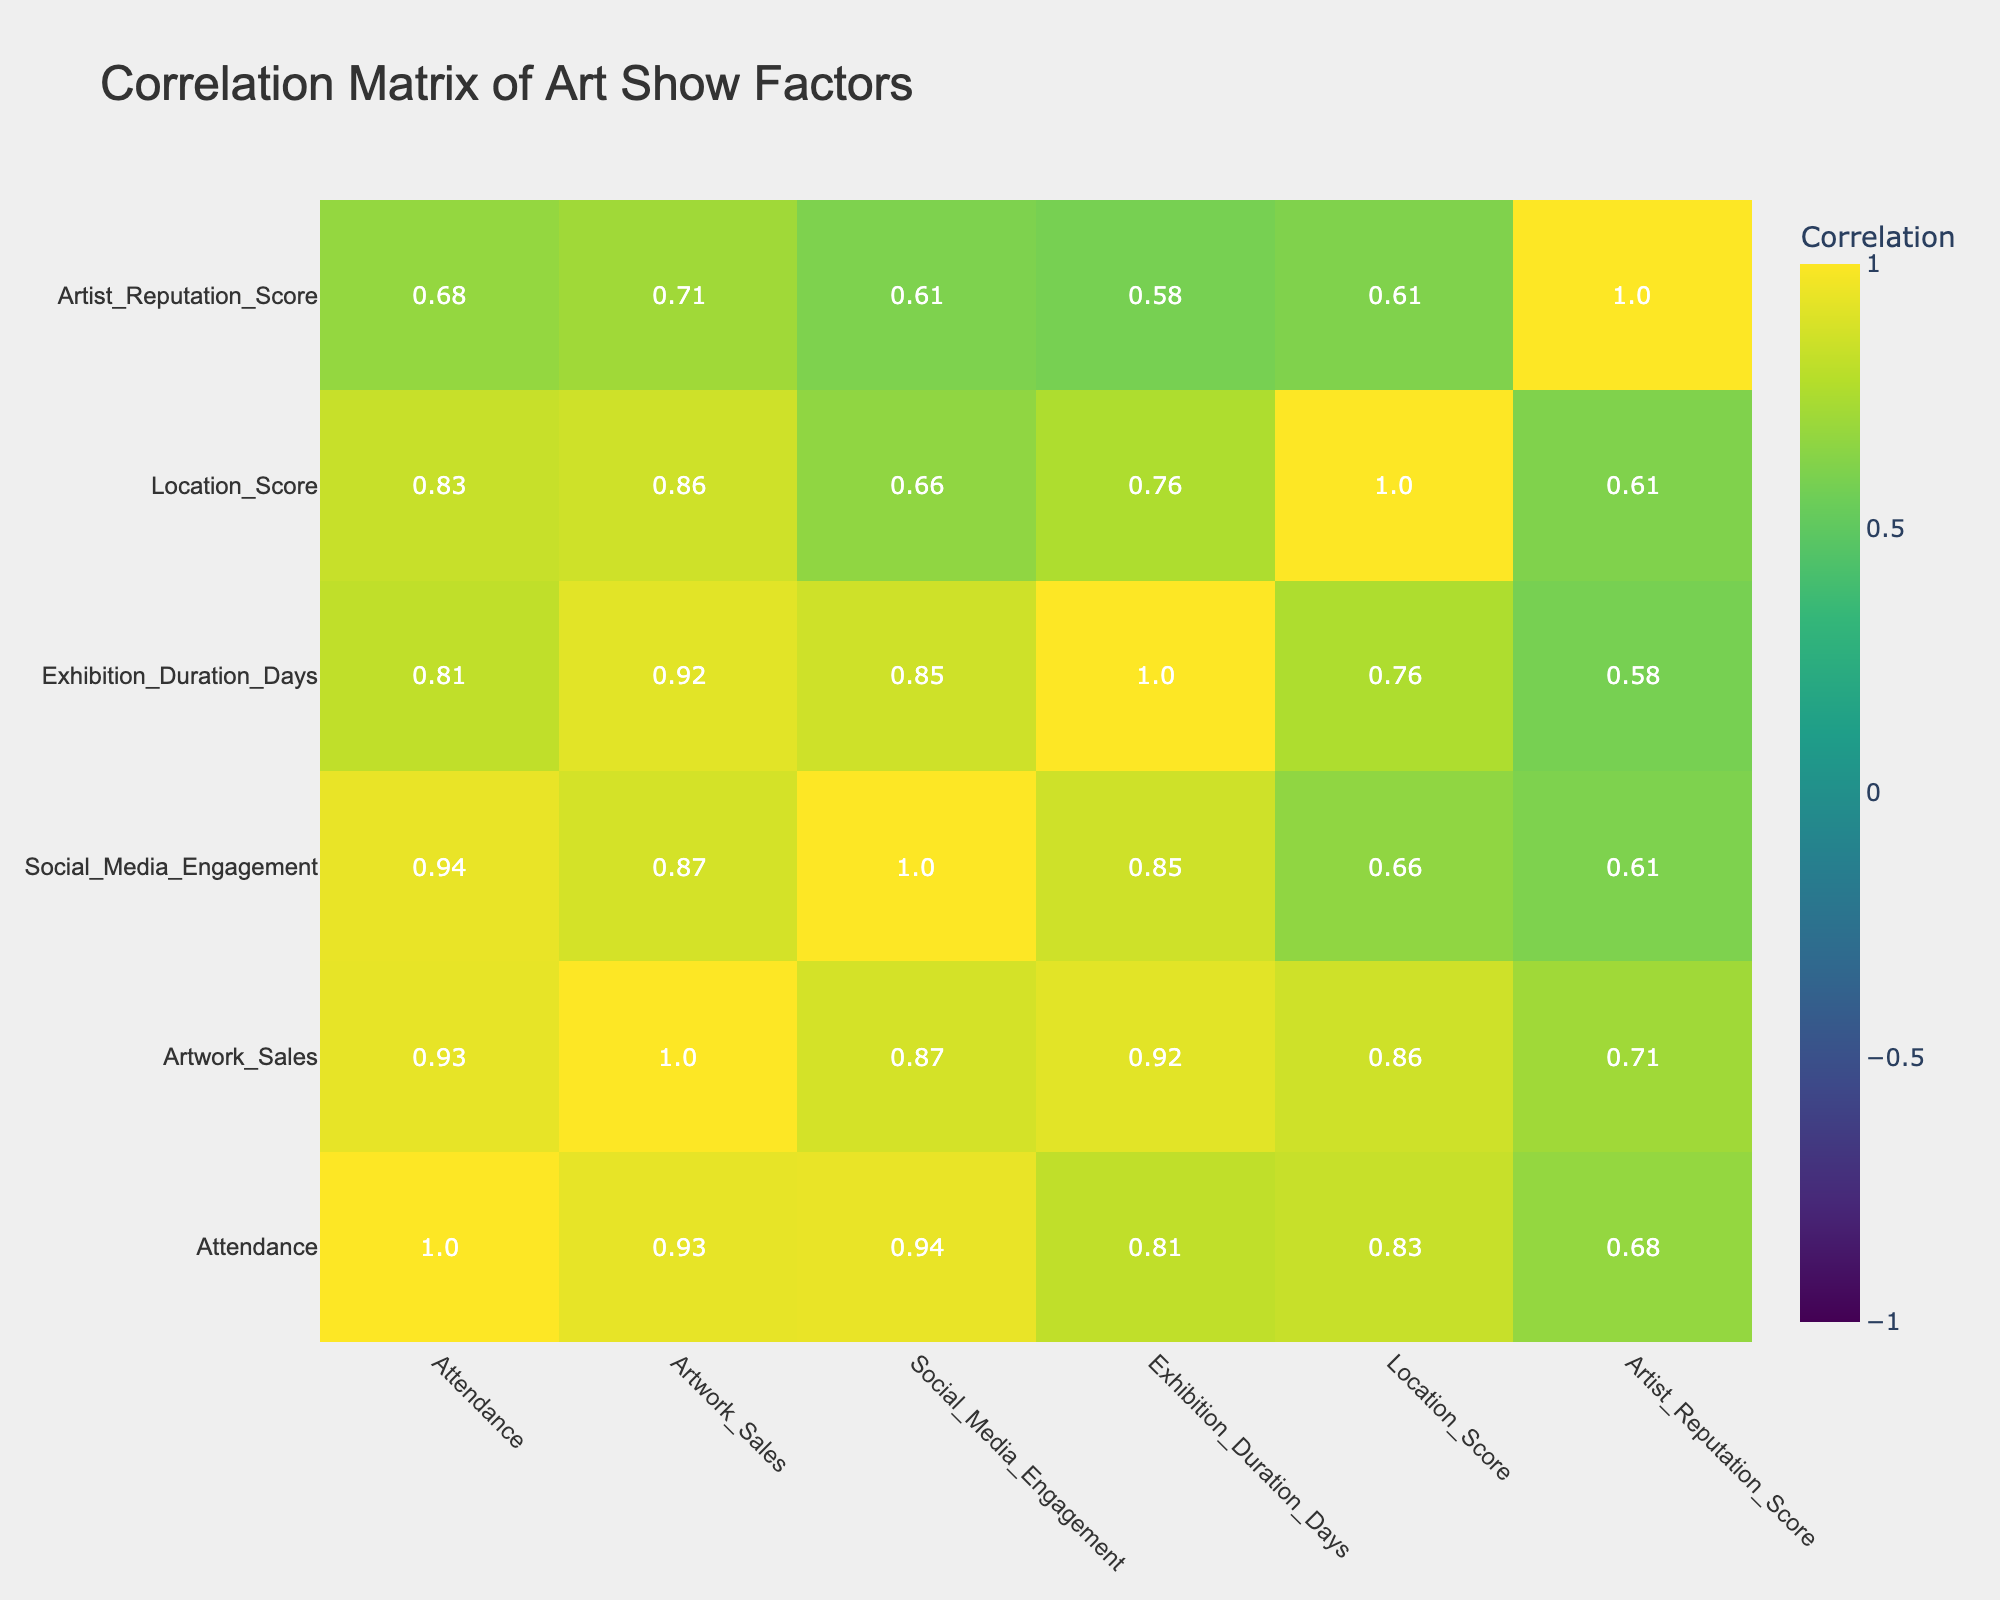What is the attendance at Rotterdam Art Fair? The table shows the attendance for each art show. Looking at the row for Rotterdam Art Fair, the attendance is listed as 2500.
Answer: 2500 What is the total artwork sales for all shows combined? To find the total artwork sales, we sum the values in the Artwork Sales column: 30000 + 45000 + 12000 + 18000 + 25000 + 8000 + 15000 + 35000 = 168000.
Answer: 168000 Is the Social Media Engagement score higher for the Amsterdam Spring Show compared to Groningen Fine Art Show? The table lists the Social Media Engagement scores as 200 for Amsterdam Spring Show and 75 for Groningen Fine Art Show. Since 200 is greater than 75, the statement is true.
Answer: Yes What is the average attendance of the shows held in cities with a Location Score of 8 or more? From the data, the shows with a Location Score of 8 or more are Rotterdam Art Fair (2500), Amsterdam Spring Show (1500), and Nijmegen Contemporary Art (1300). The total attendance for these is 2500 + 1500 + 1300 = 5300. There are three shows, so the average attendance is 5300 / 3 = approximately 1766.67.
Answer: 1766.67 Which show has the highest Artist Reputation Score? The Artist Reputation Scores for the shows are as follows: Amsterdam Spring Show (9), Rotterdam Art Fair (8), Utrecht Modern Art (6), Den Haag Painting Exhibition (7), Eindhoven Innovative Arts (8), Groningen Fine Art Show (5), Leiden Art Weekend (7), and Nijmegen Contemporary Art (7). The highest score is 9 for Amsterdam Spring Show.
Answer: Amsterdam Spring Show How is the relationship between Exhibition Duration Days and Artwork Sales? To determine the relationship, we can look for the correlation coefficient between Exhibition Duration Days and Artwork Sales in the correlation table. If it's close to 1 or -1, that indicates a strong relationship; however, if it’s close to 0, it indicates a weak relationship. Checking the table, we see that the correlation coefficient is approximately 0.72, indicating a positive relationship.
Answer: Strong positive correlation Which city has the lowest attendance and what might be a contributing factor? From the table, the city with the lowest attendance is Groningen, with an attendance of 600. Factors that could contribute include a lower Location Score of 5 and lower Social Media Engagement (75) compared to other cities.
Answer: Groningen, with a Location Score of 5 What is the median Artwork Sales among all shows? We first list the Artwork Sales values: 30000, 45000, 12000, 18000, 25000, 8000, 15000, 35000. When arranged in ascending order: 8000, 12000, 15000, 18000, 25000, 30000, 35000, 45000. There are eight shows, so the median is the average of the 4th and 5th values, which are 18000 and 25000. The median is (18000 + 25000) / 2 = 21500.
Answer: 21500 What factors are correlated with higher attendance? By examining the correlation table, we can see which factors have a high positive correlation with attendance. Social Media Engagement (0.93) and Artist Reputation Score (0.85) both show strong positive correlations. This suggests that higher engagement and reputation are associated with higher attendance.
Answer: Social Media Engagement and Artist Reputation Score 